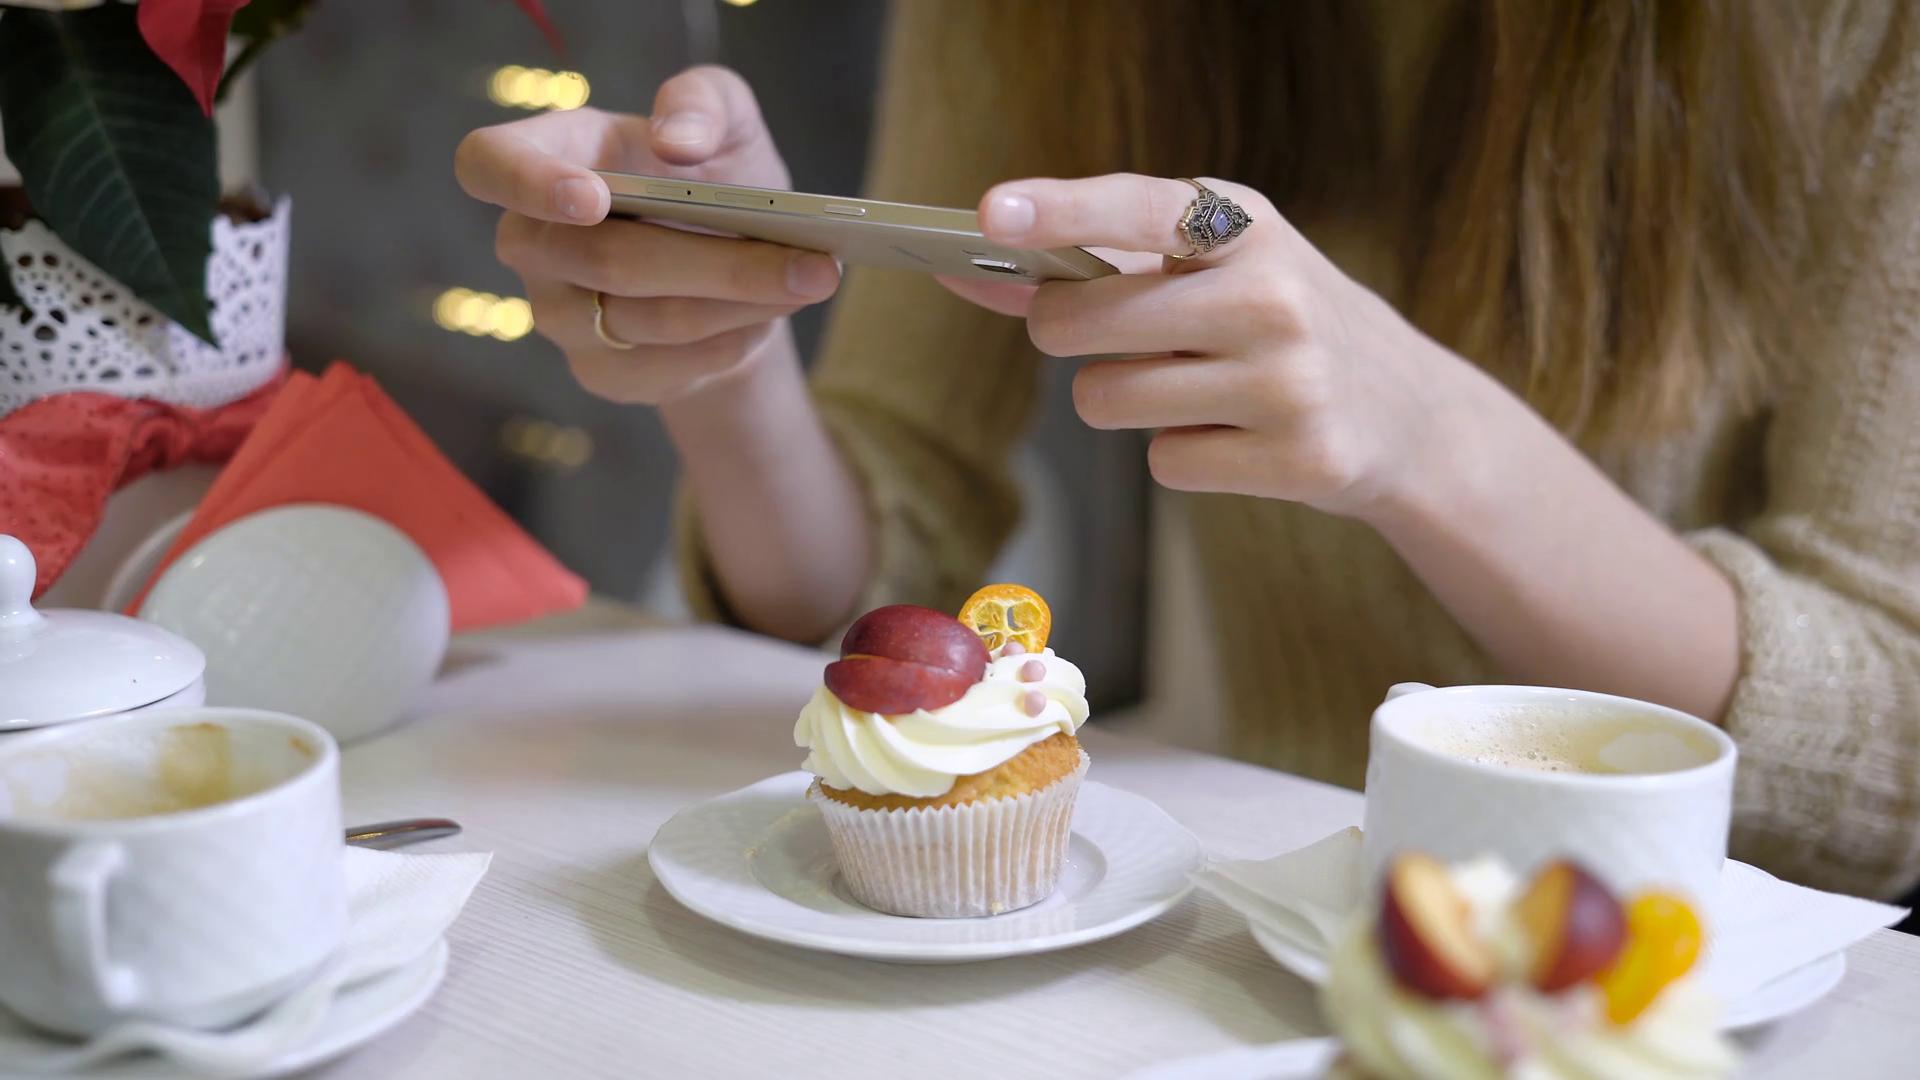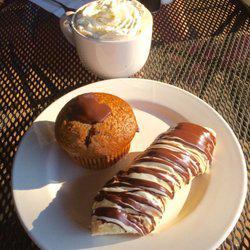The first image is the image on the left, the second image is the image on the right. Considering the images on both sides, is "One of the images has a human being visible." valid? Answer yes or no. Yes. 